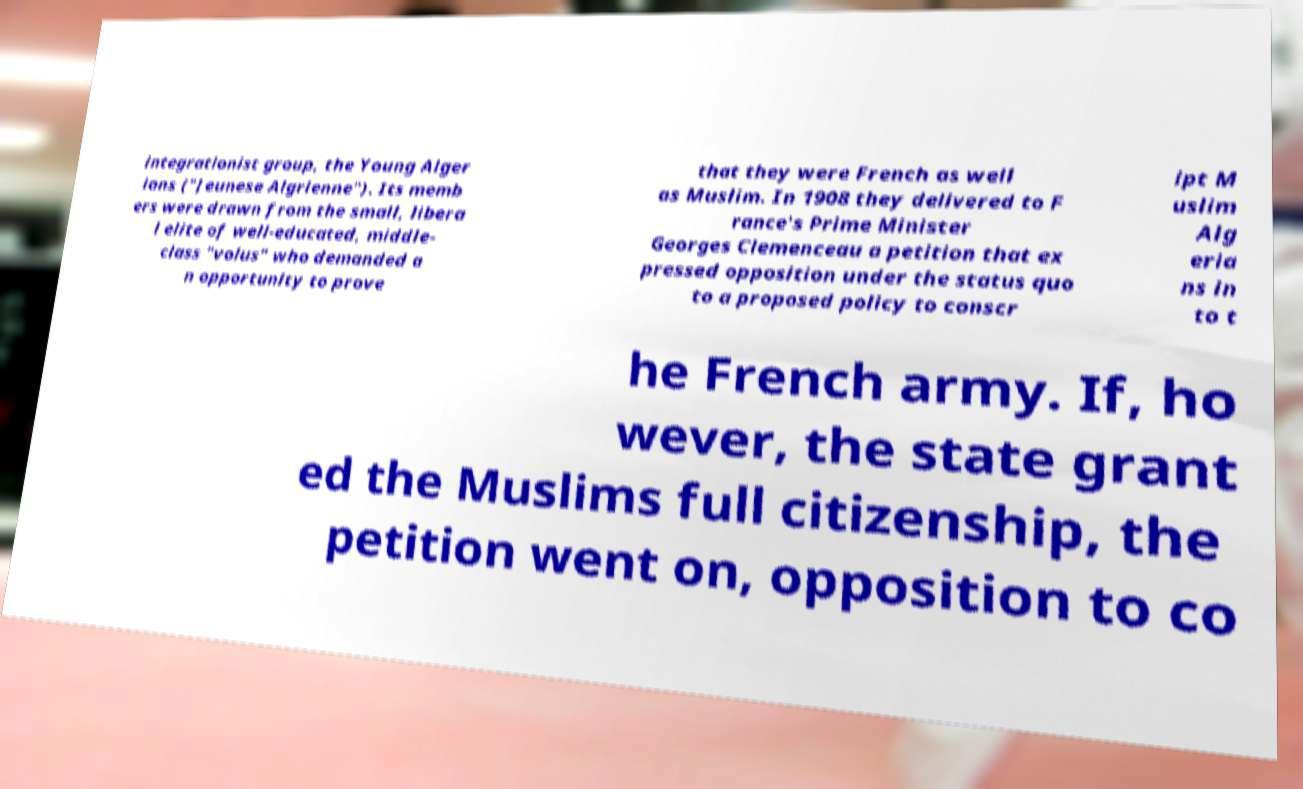What messages or text are displayed in this image? I need them in a readable, typed format. integrationist group, the Young Alger ians ("Jeunese Algrienne"). Its memb ers were drawn from the small, libera l elite of well-educated, middle- class "volus" who demanded a n opportunity to prove that they were French as well as Muslim. In 1908 they delivered to F rance's Prime Minister Georges Clemenceau a petition that ex pressed opposition under the status quo to a proposed policy to conscr ipt M uslim Alg eria ns in to t he French army. If, ho wever, the state grant ed the Muslims full citizenship, the petition went on, opposition to co 